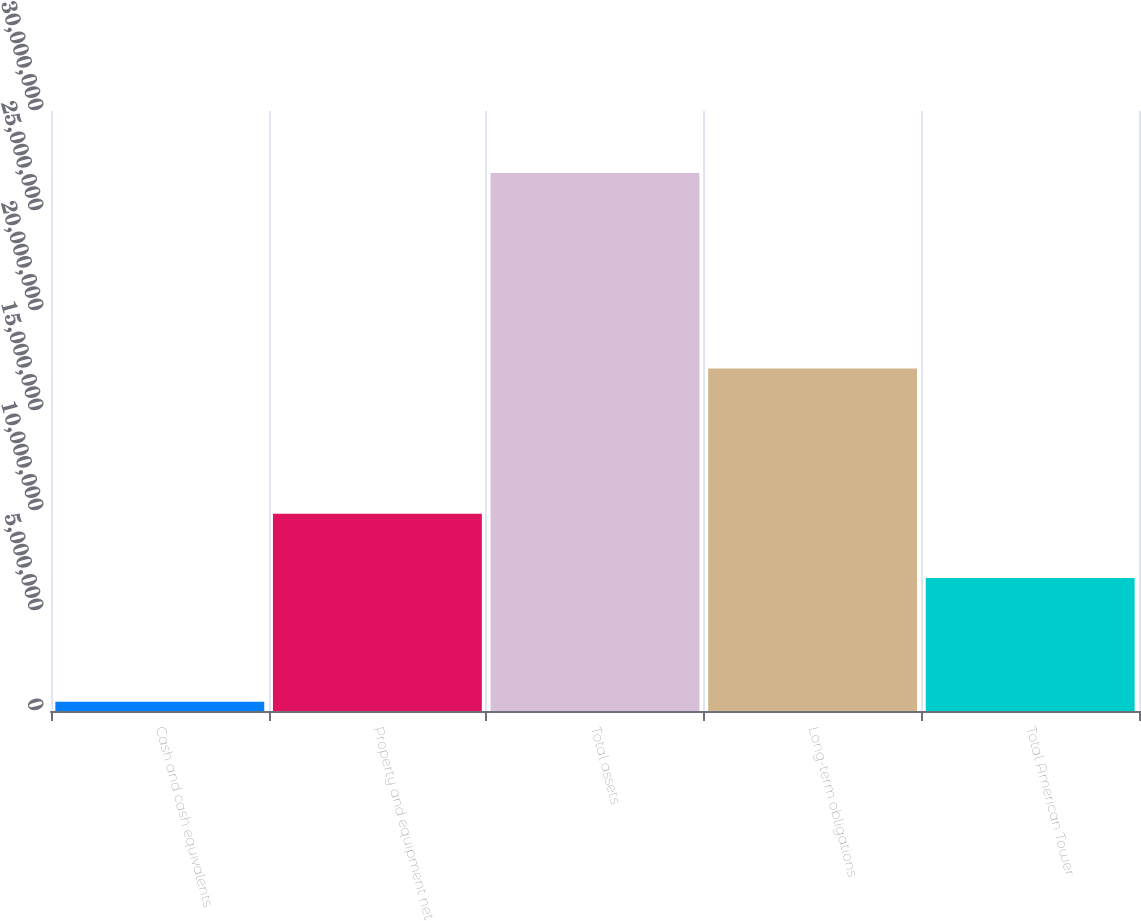Convert chart. <chart><loc_0><loc_0><loc_500><loc_500><bar_chart><fcel>Cash and cash equivalents<fcel>Property and equipment net<fcel>Total assets<fcel>Long-term obligations<fcel>Total American Tower<nl><fcel>462879<fcel>9.86642e+06<fcel>2.69043e+07<fcel>1.7119e+07<fcel>6.65168e+06<nl></chart> 